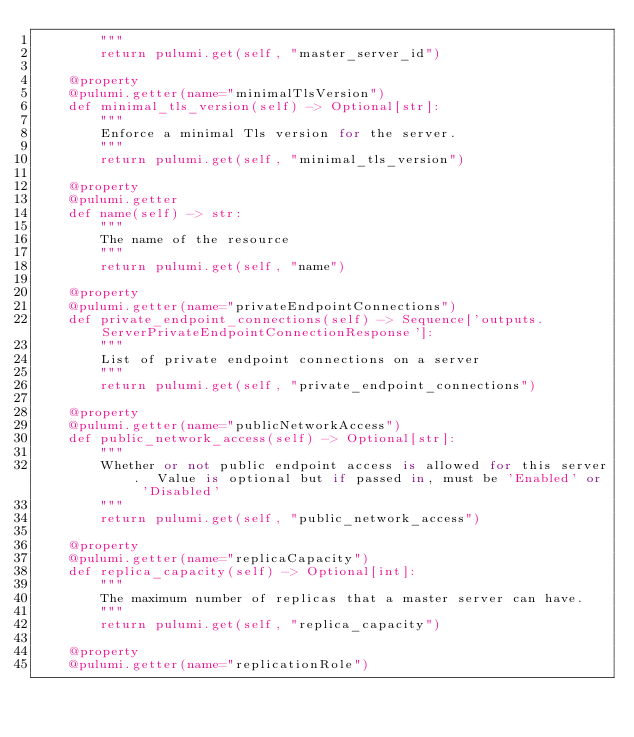Convert code to text. <code><loc_0><loc_0><loc_500><loc_500><_Python_>        """
        return pulumi.get(self, "master_server_id")

    @property
    @pulumi.getter(name="minimalTlsVersion")
    def minimal_tls_version(self) -> Optional[str]:
        """
        Enforce a minimal Tls version for the server.
        """
        return pulumi.get(self, "minimal_tls_version")

    @property
    @pulumi.getter
    def name(self) -> str:
        """
        The name of the resource
        """
        return pulumi.get(self, "name")

    @property
    @pulumi.getter(name="privateEndpointConnections")
    def private_endpoint_connections(self) -> Sequence['outputs.ServerPrivateEndpointConnectionResponse']:
        """
        List of private endpoint connections on a server
        """
        return pulumi.get(self, "private_endpoint_connections")

    @property
    @pulumi.getter(name="publicNetworkAccess")
    def public_network_access(self) -> Optional[str]:
        """
        Whether or not public endpoint access is allowed for this server.  Value is optional but if passed in, must be 'Enabled' or 'Disabled'
        """
        return pulumi.get(self, "public_network_access")

    @property
    @pulumi.getter(name="replicaCapacity")
    def replica_capacity(self) -> Optional[int]:
        """
        The maximum number of replicas that a master server can have.
        """
        return pulumi.get(self, "replica_capacity")

    @property
    @pulumi.getter(name="replicationRole")</code> 